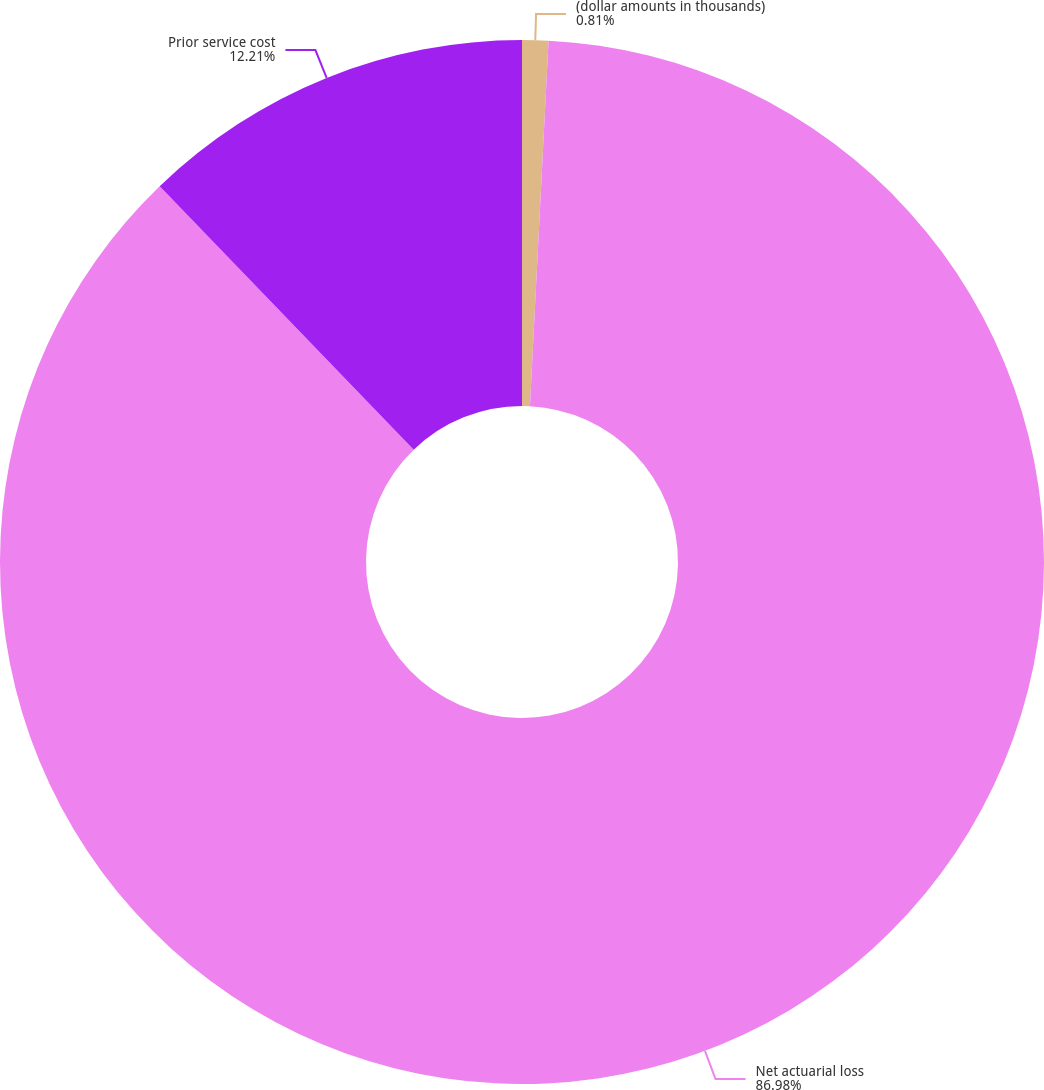Convert chart. <chart><loc_0><loc_0><loc_500><loc_500><pie_chart><fcel>(dollar amounts in thousands)<fcel>Net actuarial loss<fcel>Prior service cost<nl><fcel>0.81%<fcel>86.98%<fcel>12.21%<nl></chart> 